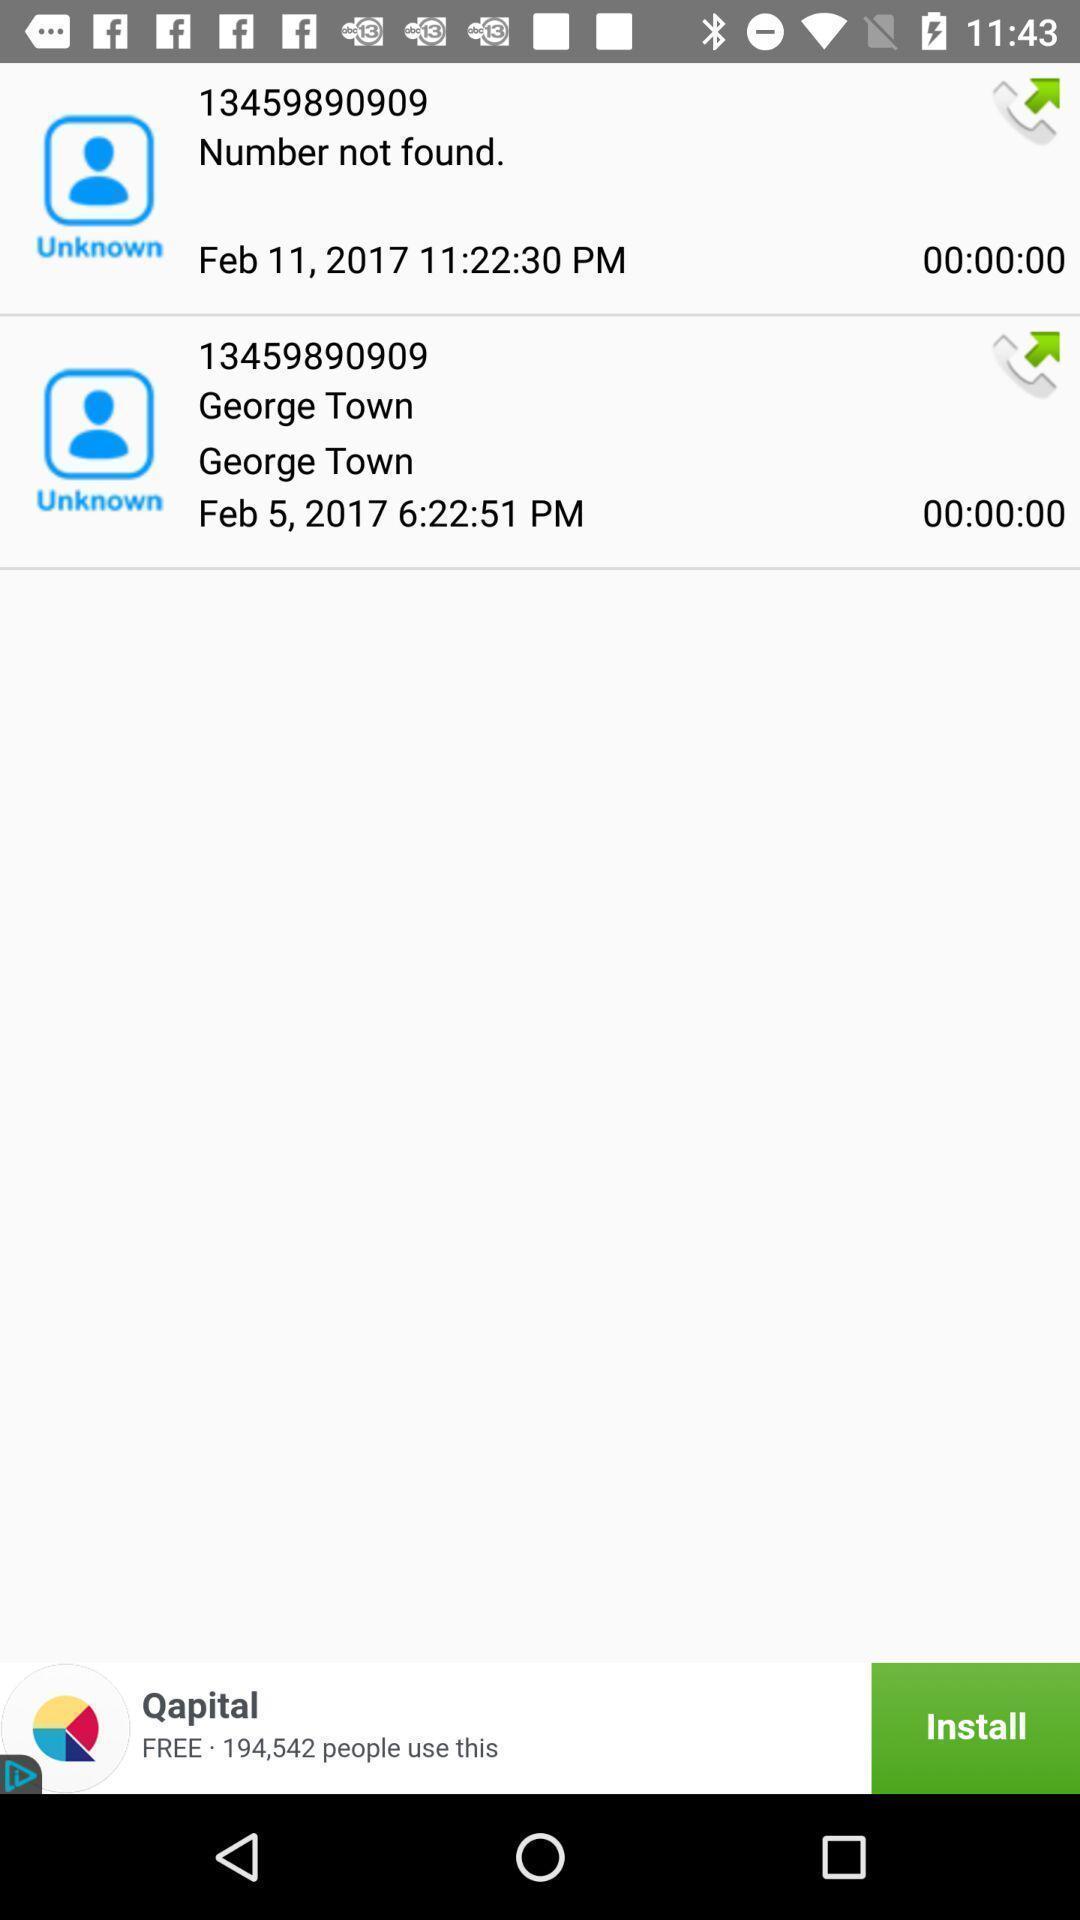Summarize the main components in this picture. Page displaying various mobile numbers in tracking application. 